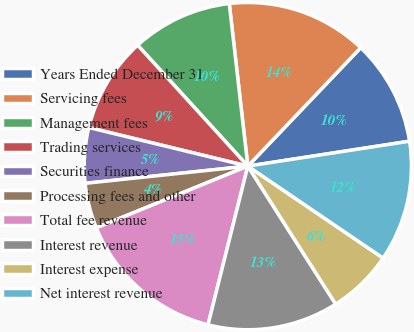Convert chart. <chart><loc_0><loc_0><loc_500><loc_500><pie_chart><fcel>Years Ended December 31<fcel>Servicing fees<fcel>Management fees<fcel>Trading services<fcel>Securities finance<fcel>Processing fees and other<fcel>Total fee revenue<fcel>Interest revenue<fcel>Interest expense<fcel>Net interest revenue<nl><fcel>10.45%<fcel>13.93%<fcel>9.95%<fcel>9.45%<fcel>5.47%<fcel>4.48%<fcel>14.93%<fcel>12.94%<fcel>6.47%<fcel>11.94%<nl></chart> 